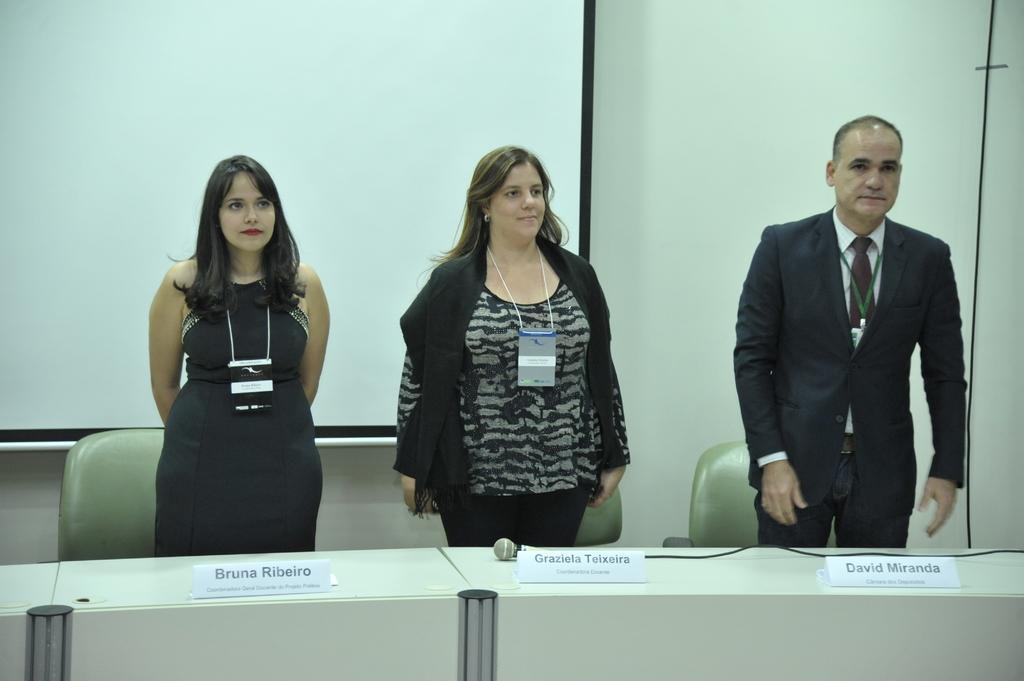Could you give a brief overview of what you see in this image? In this image we can see three people standing beside a table containing a mic with a wire and some name boards on it. On the backside we can see some chairs, a wall, wire and a display screen. 